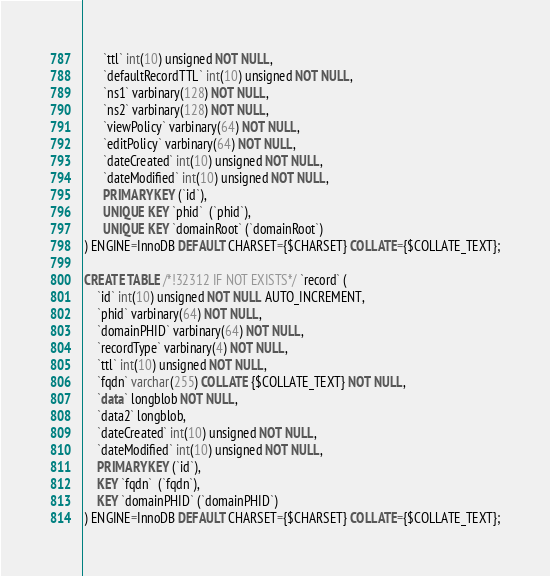Convert code to text. <code><loc_0><loc_0><loc_500><loc_500><_SQL_>      `ttl` int(10) unsigned NOT NULL,
      `defaultRecordTTL` int(10) unsigned NOT NULL,
      `ns1` varbinary(128) NOT NULL,
      `ns2` varbinary(128) NOT NULL,
      `viewPolicy` varbinary(64) NOT NULL,
      `editPolicy` varbinary(64) NOT NULL,
      `dateCreated` int(10) unsigned NOT NULL,
      `dateModified` int(10) unsigned NOT NULL,
      PRIMARY KEY (`id`),
      UNIQUE KEY `phid`  (`phid`),
      UNIQUE KEY `domainRoot` (`domainRoot`)
) ENGINE=InnoDB DEFAULT CHARSET={$CHARSET} COLLATE={$COLLATE_TEXT};

CREATE TABLE /*!32312 IF NOT EXISTS*/ `record` (
    `id` int(10) unsigned NOT NULL AUTO_INCREMENT,
    `phid` varbinary(64) NOT NULL,
    `domainPHID` varbinary(64) NOT NULL,
    `recordType` varbinary(4) NOT NULL,
    `ttl` int(10) unsigned NOT NULL,
    `fqdn` varchar(255) COLLATE {$COLLATE_TEXT} NOT NULL,
    `data` longblob NOT NULL,
    `data2` longblob,
    `dateCreated` int(10) unsigned NOT NULL,
    `dateModified` int(10) unsigned NOT NULL,
    PRIMARY KEY (`id`),
    KEY `fqdn`  (`fqdn`),
    KEY `domainPHID` (`domainPHID`)
) ENGINE=InnoDB DEFAULT CHARSET={$CHARSET} COLLATE={$COLLATE_TEXT};

</code> 